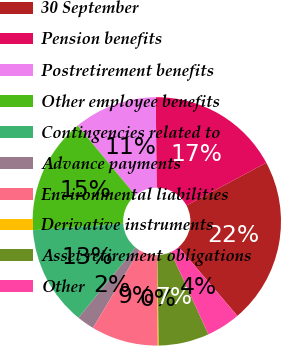Convert chart. <chart><loc_0><loc_0><loc_500><loc_500><pie_chart><fcel>30 September<fcel>Pension benefits<fcel>Postretirement benefits<fcel>Other employee benefits<fcel>Contingencies related to<fcel>Advance payments<fcel>Environmental liabilities<fcel>Derivative instruments<fcel>Asset retirement obligations<fcel>Other<nl><fcel>21.59%<fcel>17.3%<fcel>10.86%<fcel>15.15%<fcel>13.0%<fcel>2.27%<fcel>8.71%<fcel>0.13%<fcel>6.57%<fcel>4.42%<nl></chart> 